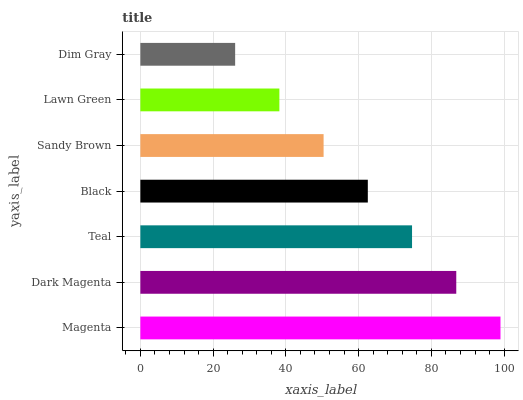Is Dim Gray the minimum?
Answer yes or no. Yes. Is Magenta the maximum?
Answer yes or no. Yes. Is Dark Magenta the minimum?
Answer yes or no. No. Is Dark Magenta the maximum?
Answer yes or no. No. Is Magenta greater than Dark Magenta?
Answer yes or no. Yes. Is Dark Magenta less than Magenta?
Answer yes or no. Yes. Is Dark Magenta greater than Magenta?
Answer yes or no. No. Is Magenta less than Dark Magenta?
Answer yes or no. No. Is Black the high median?
Answer yes or no. Yes. Is Black the low median?
Answer yes or no. Yes. Is Dim Gray the high median?
Answer yes or no. No. Is Teal the low median?
Answer yes or no. No. 